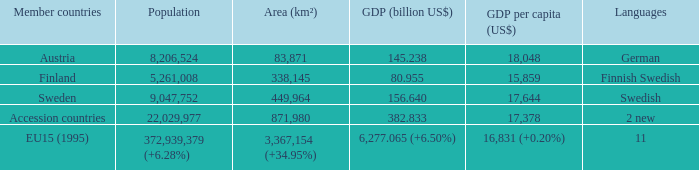Name the area for german 83871.0. 